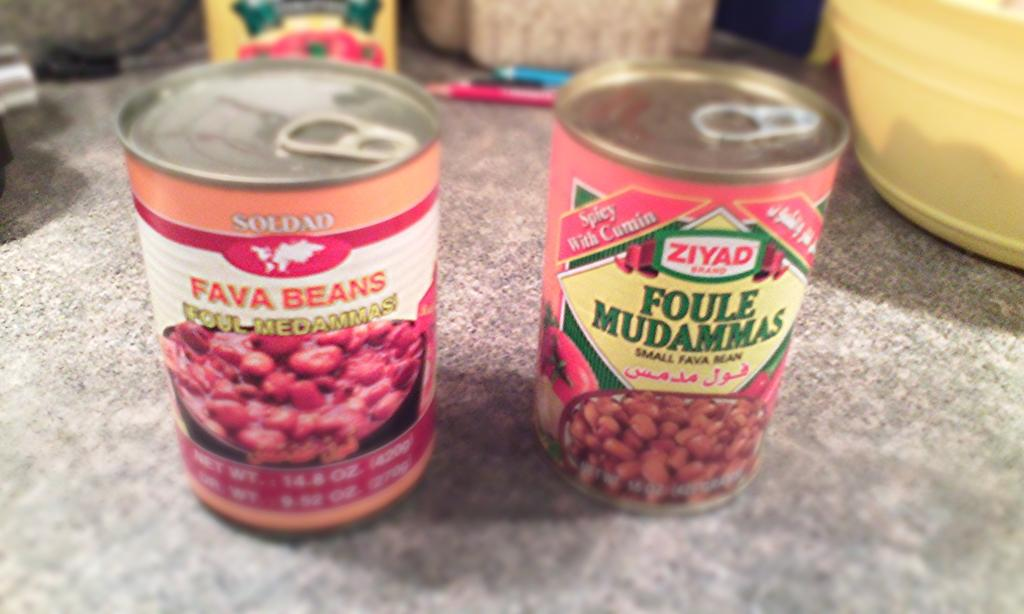<image>
Present a compact description of the photo's key features. A pink can has an image and text of fava beans. 